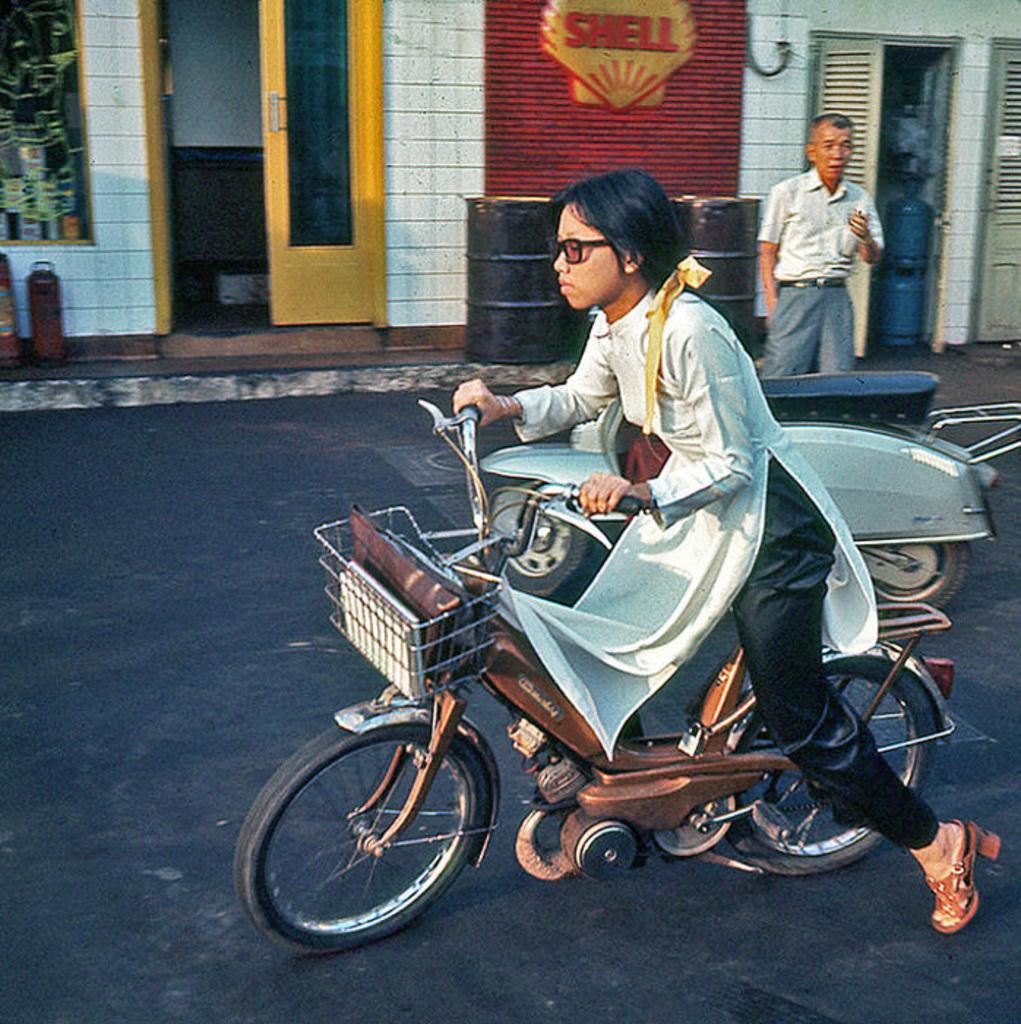Describe this image in one or two sentences. In this image there is one women is riding a bike as we can see at bottom of this image. There is one other bike is at right side to this women, and there is one person standing at top right side of this image. There is a house at top of this image and there are some objects kept at left side of this image. There is a road at bottom of this image. 